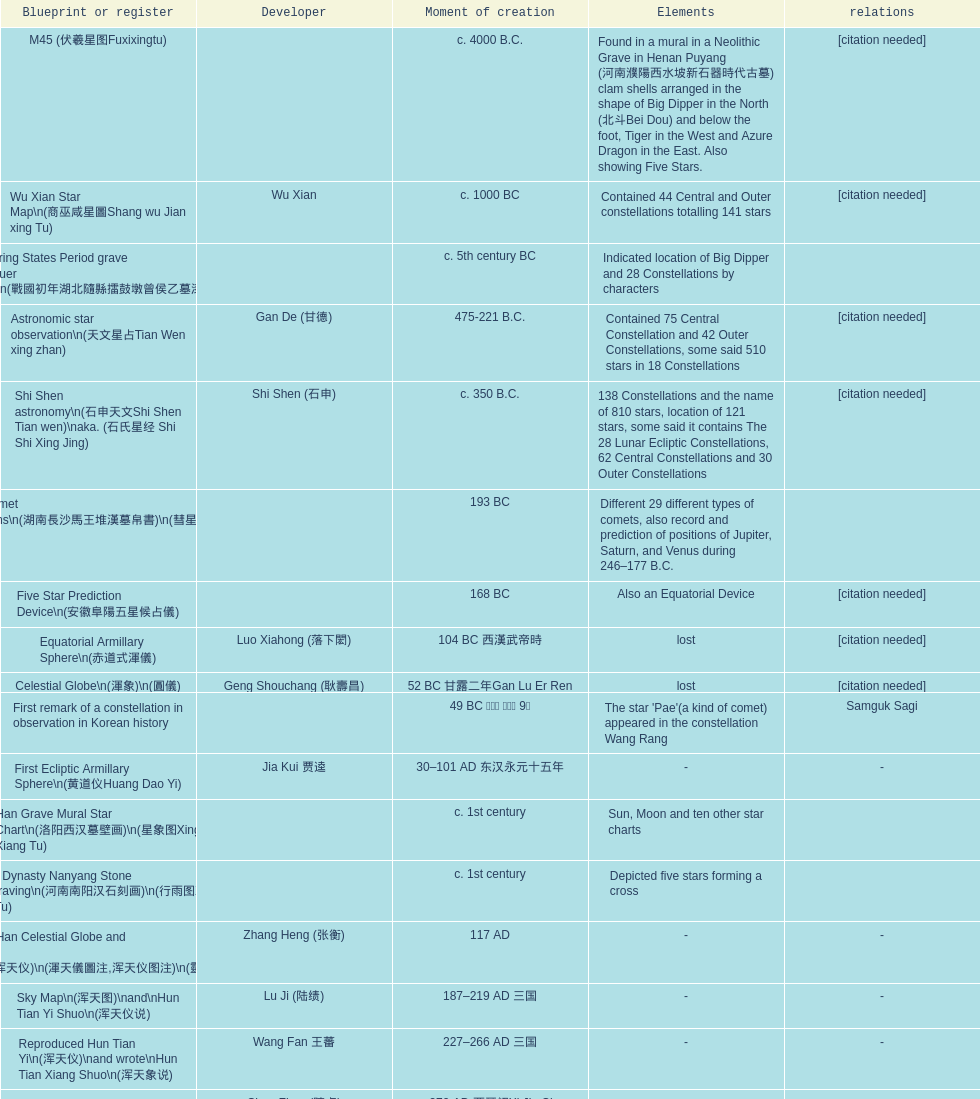What is the name of the oldest map/catalog? M45. 